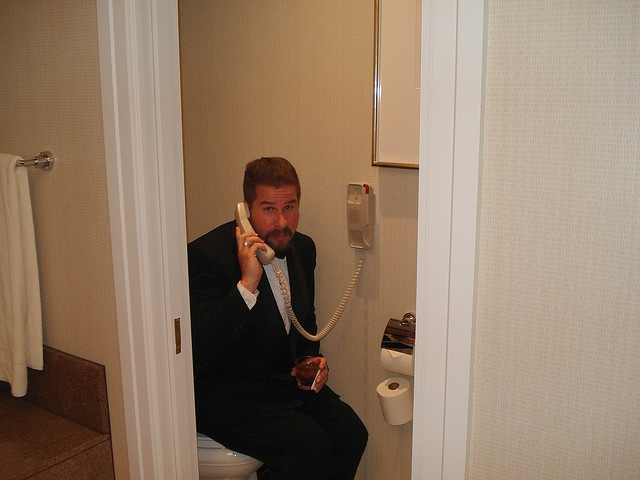Describe the objects in this image and their specific colors. I can see people in maroon, black, gray, and brown tones, toilet in maroon, gray, brown, and black tones, and cup in maroon, black, and brown tones in this image. 